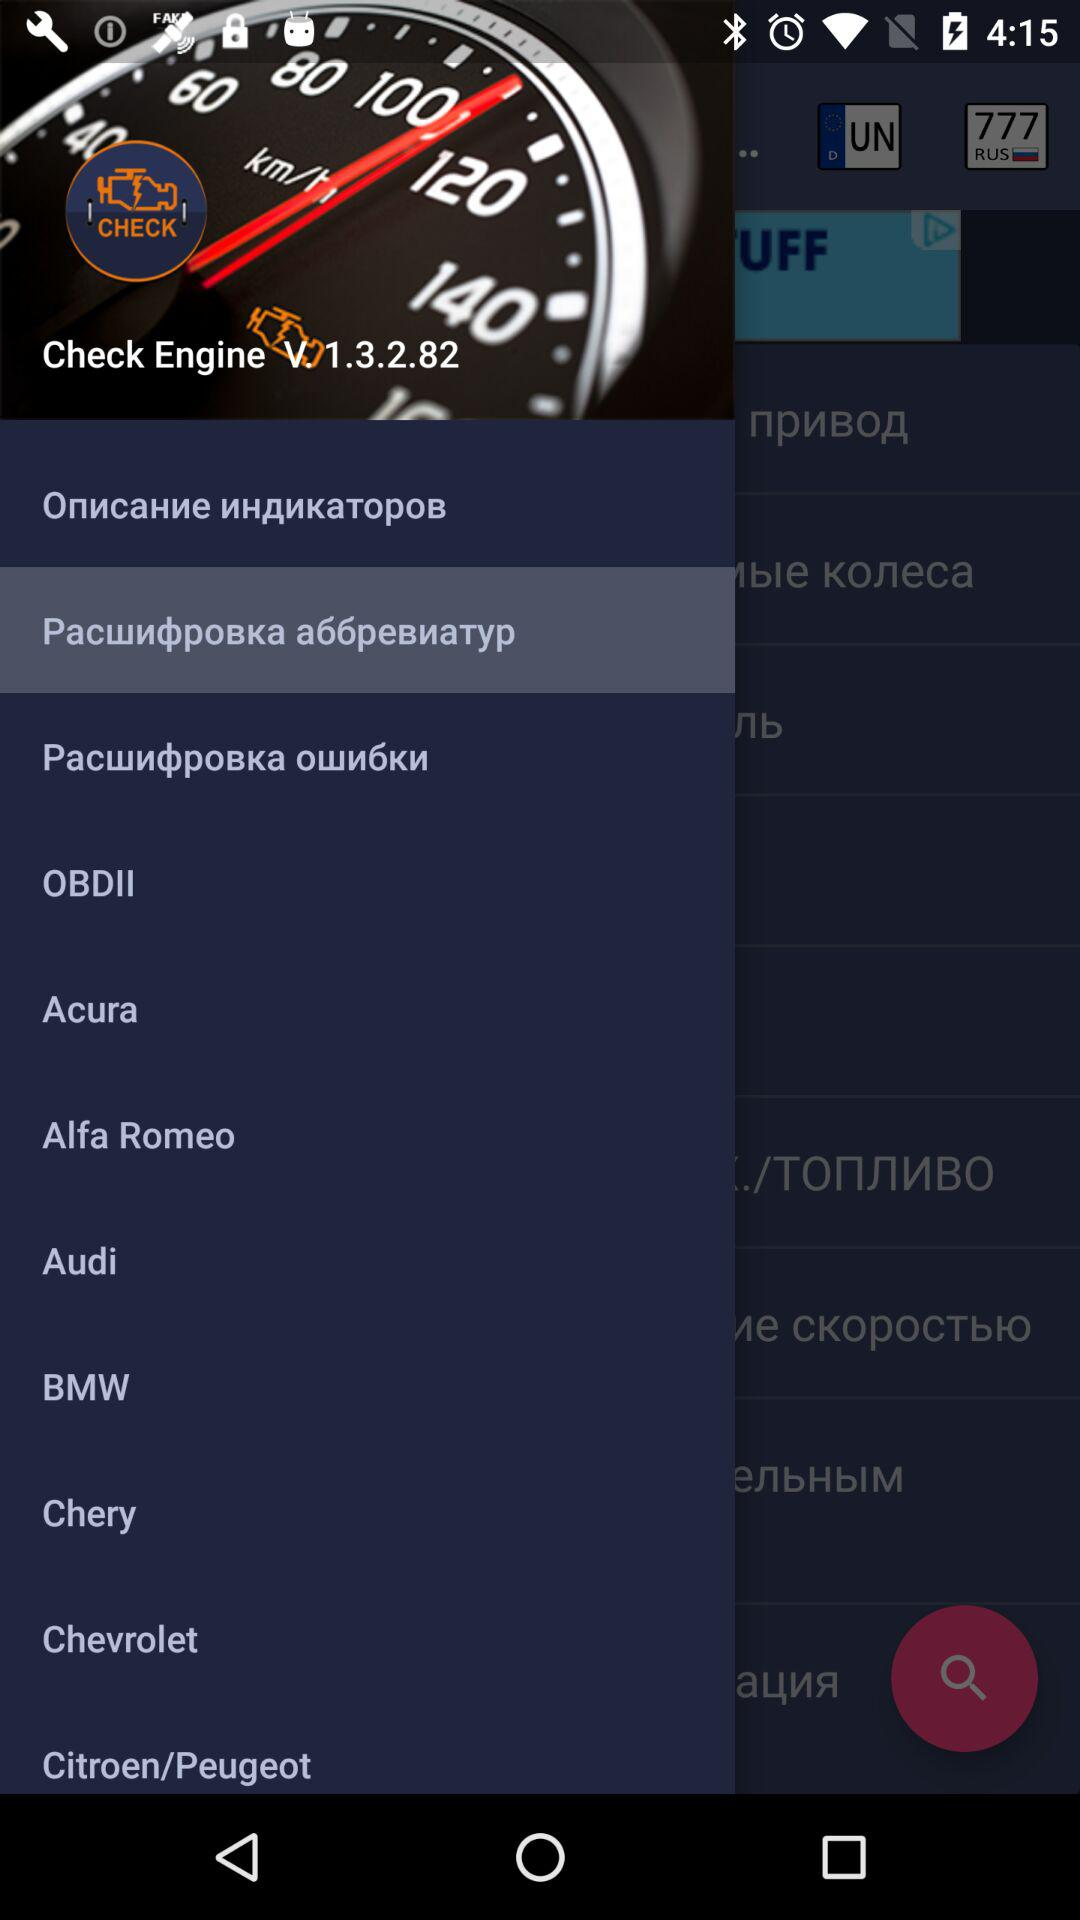What is the version of "Check Engine"? The version is V. 1.3.2.82. 